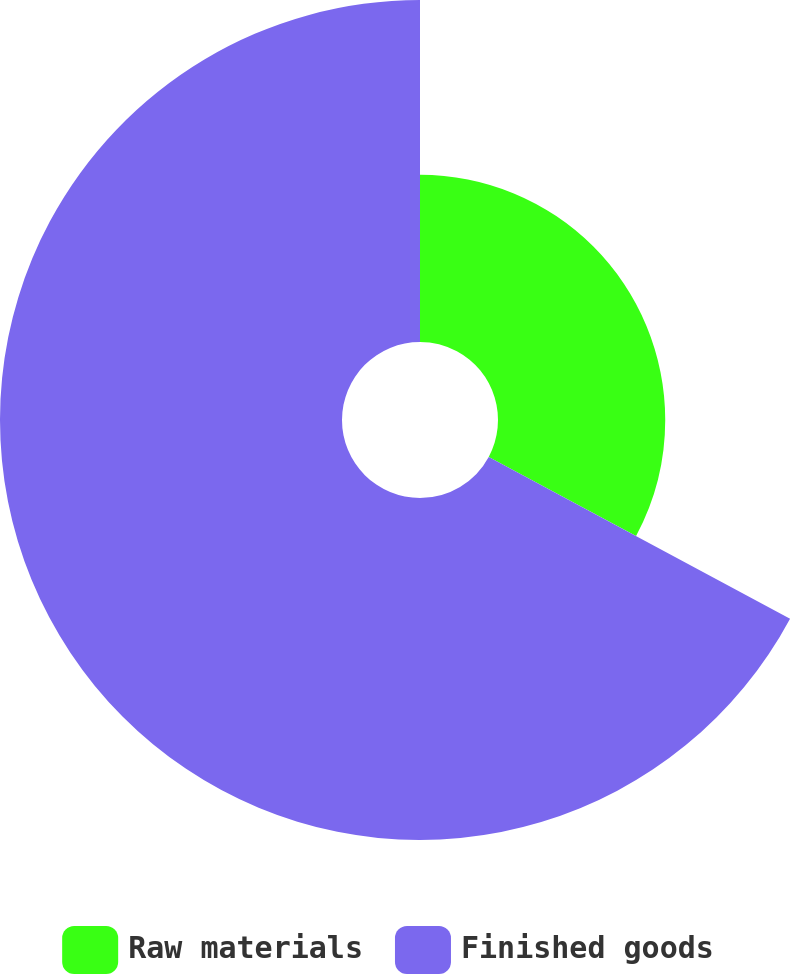Convert chart. <chart><loc_0><loc_0><loc_500><loc_500><pie_chart><fcel>Raw materials<fcel>Finished goods<nl><fcel>32.84%<fcel>67.16%<nl></chart> 